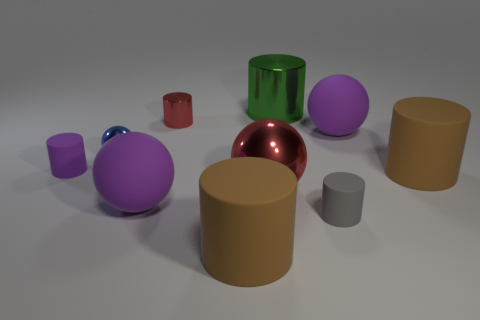Subtract all purple cylinders. How many cylinders are left? 5 Subtract 1 balls. How many balls are left? 3 Subtract all gray matte cylinders. How many cylinders are left? 5 Subtract all gray balls. Subtract all red cylinders. How many balls are left? 4 Subtract 0 yellow balls. How many objects are left? 10 Subtract all balls. How many objects are left? 6 Subtract all tiny purple metallic spheres. Subtract all matte balls. How many objects are left? 8 Add 5 purple rubber cylinders. How many purple rubber cylinders are left? 6 Add 1 small cylinders. How many small cylinders exist? 4 